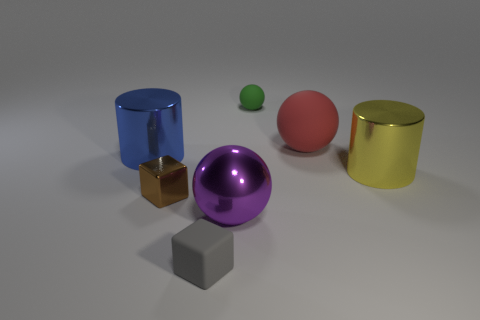Add 3 red objects. How many objects exist? 10 Subtract all green balls. How many balls are left? 2 Subtract 1 balls. How many balls are left? 2 Subtract all purple spheres. How many spheres are left? 2 Subtract all cylinders. How many objects are left? 5 Subtract all balls. Subtract all tiny metallic spheres. How many objects are left? 4 Add 5 big spheres. How many big spheres are left? 7 Add 5 cyan metal cylinders. How many cyan metal cylinders exist? 5 Subtract 0 blue cubes. How many objects are left? 7 Subtract all yellow blocks. Subtract all yellow cylinders. How many blocks are left? 2 